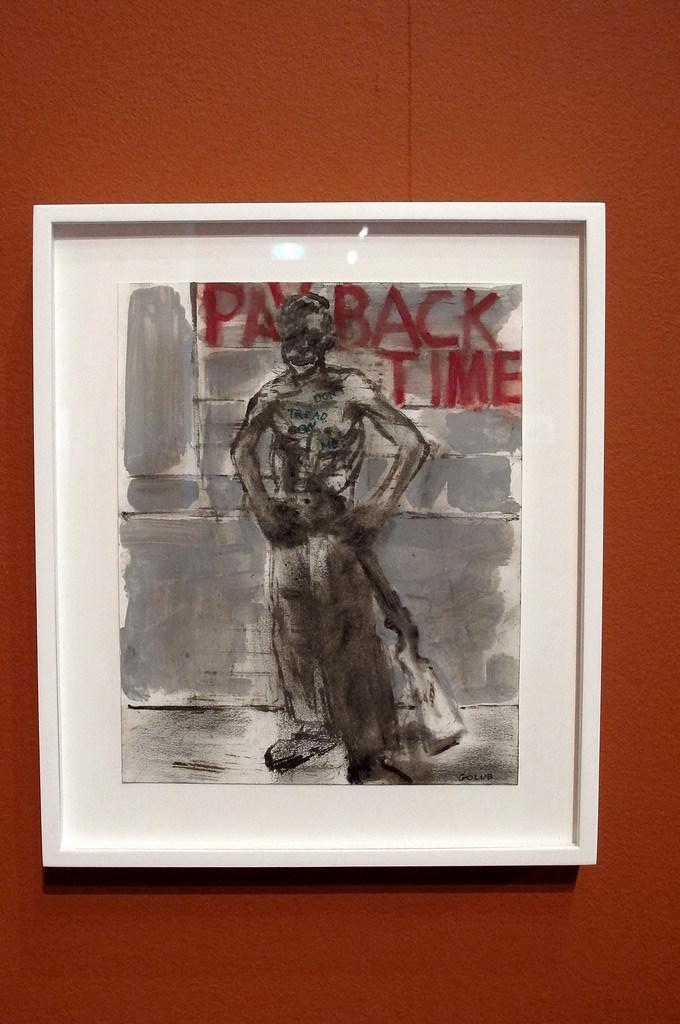<image>
Write a terse but informative summary of the picture. A frame that has a painting that has the title of payback time. 